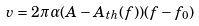<formula> <loc_0><loc_0><loc_500><loc_500>v = 2 \pi \alpha ( A - A _ { t h } ( f ) ) ( f - f _ { 0 } )</formula> 